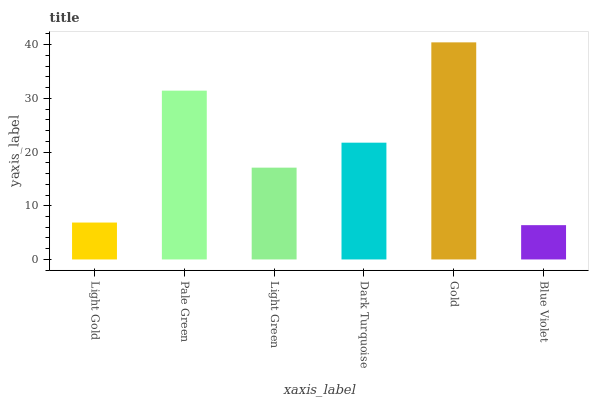Is Blue Violet the minimum?
Answer yes or no. Yes. Is Gold the maximum?
Answer yes or no. Yes. Is Pale Green the minimum?
Answer yes or no. No. Is Pale Green the maximum?
Answer yes or no. No. Is Pale Green greater than Light Gold?
Answer yes or no. Yes. Is Light Gold less than Pale Green?
Answer yes or no. Yes. Is Light Gold greater than Pale Green?
Answer yes or no. No. Is Pale Green less than Light Gold?
Answer yes or no. No. Is Dark Turquoise the high median?
Answer yes or no. Yes. Is Light Green the low median?
Answer yes or no. Yes. Is Gold the high median?
Answer yes or no. No. Is Gold the low median?
Answer yes or no. No. 